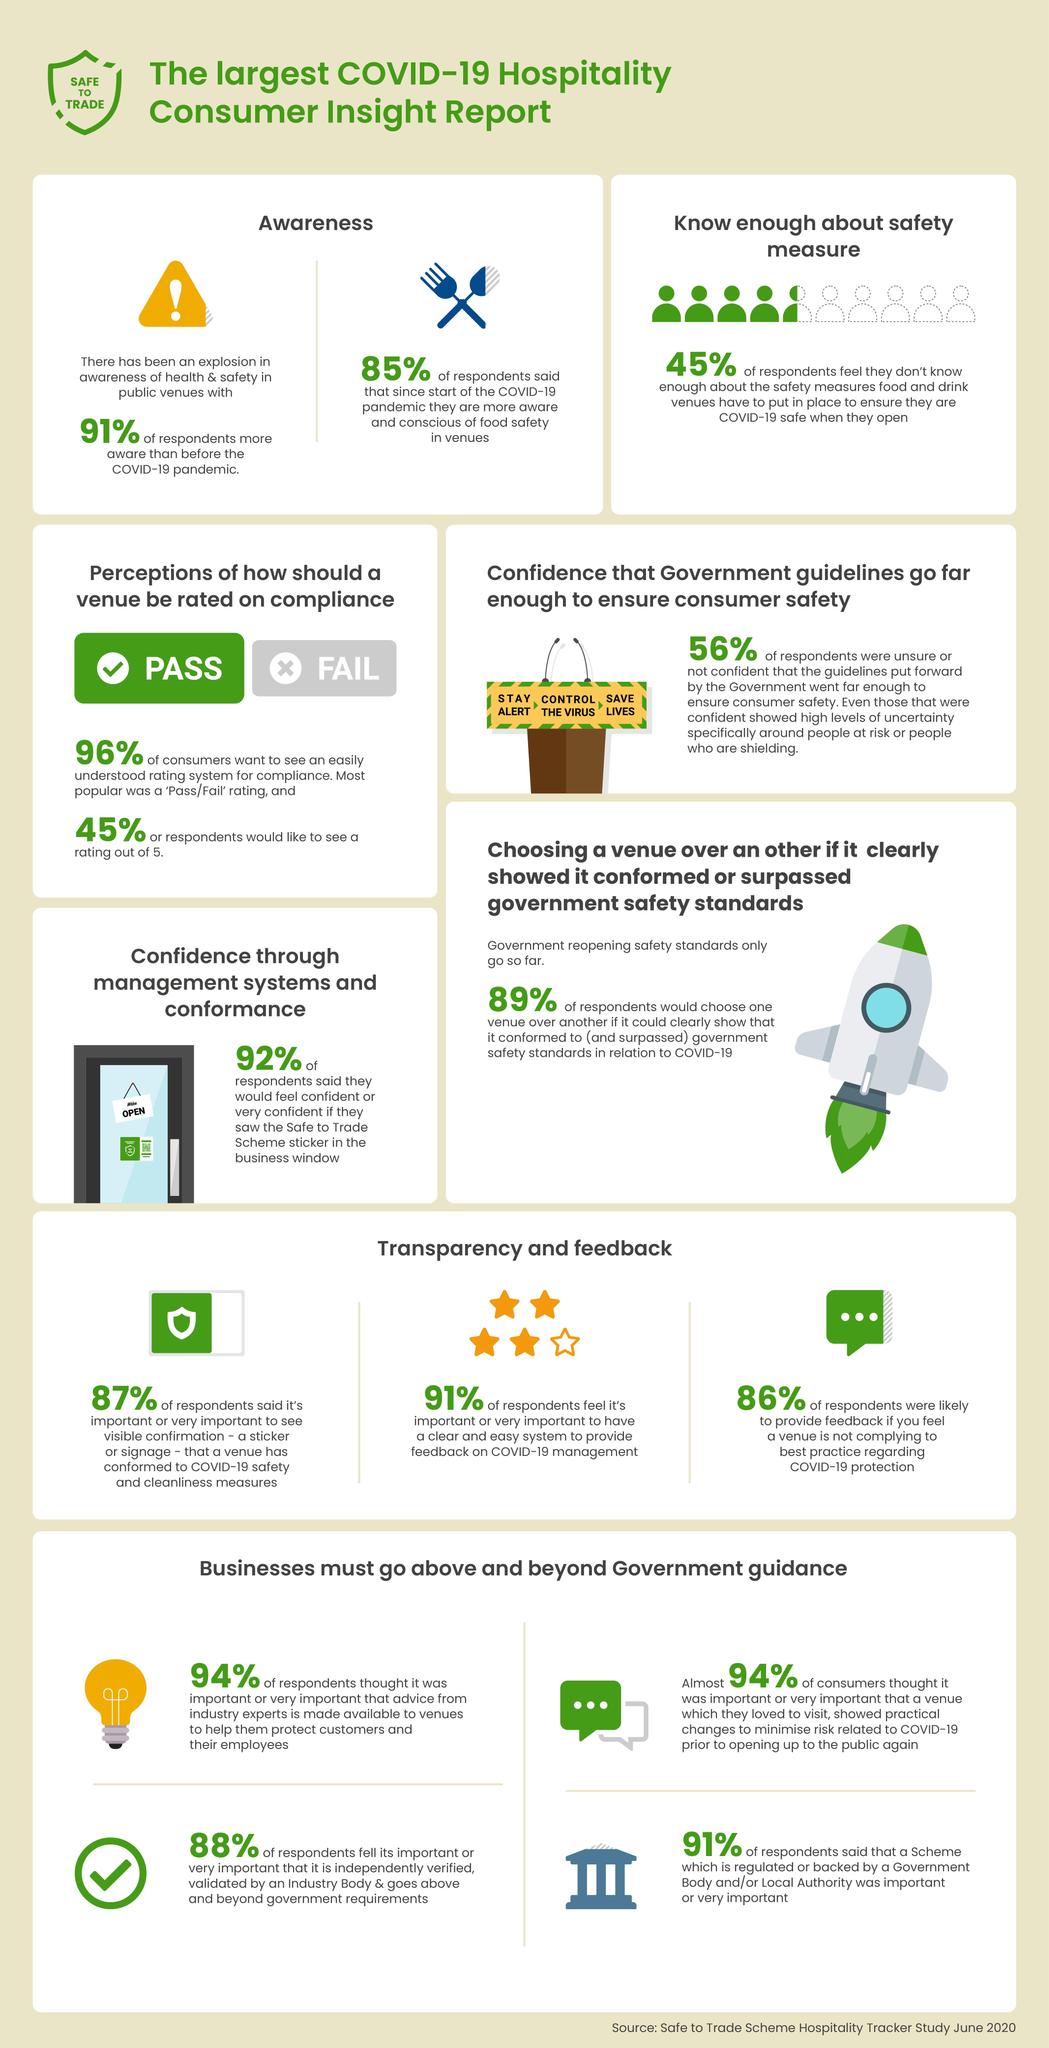Mention a couple of crucial points in this snapshot. After the COVID-19 pandemic, a significant percentage of people have become more conscious about safety and health, with 91% of individuals reporting an increased awareness of the importance of protecting themselves and others from illness. According to a survey, 56% of people were not confident in the government's ability to effectively control the spread of the pandemic. Which rating system is commonly used by people and is known for its simplicity, often using a pass/fail system? A significant 45% of people are unaware of the necessary safety precautions to be taken while in a cafeteria. According to the survey, 45% of respondents preferred a normal star rating system for the Pass/Fail system. 